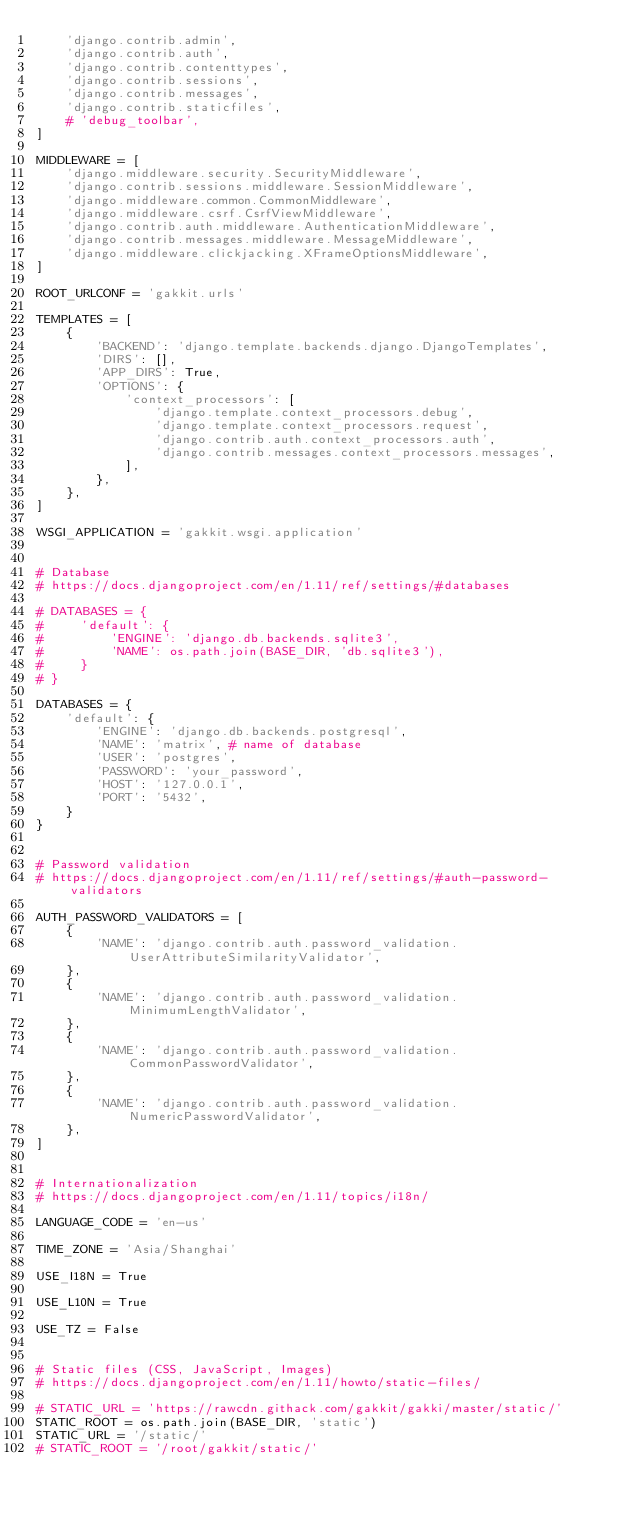<code> <loc_0><loc_0><loc_500><loc_500><_Python_>    'django.contrib.admin',
    'django.contrib.auth',
    'django.contrib.contenttypes',
    'django.contrib.sessions',
    'django.contrib.messages',
    'django.contrib.staticfiles',
    # 'debug_toolbar',
]

MIDDLEWARE = [
    'django.middleware.security.SecurityMiddleware',
    'django.contrib.sessions.middleware.SessionMiddleware',
    'django.middleware.common.CommonMiddleware',
    'django.middleware.csrf.CsrfViewMiddleware',
    'django.contrib.auth.middleware.AuthenticationMiddleware',
    'django.contrib.messages.middleware.MessageMiddleware',
    'django.middleware.clickjacking.XFrameOptionsMiddleware',
]

ROOT_URLCONF = 'gakkit.urls'

TEMPLATES = [
    {
        'BACKEND': 'django.template.backends.django.DjangoTemplates',
        'DIRS': [],
        'APP_DIRS': True,
        'OPTIONS': {
            'context_processors': [
                'django.template.context_processors.debug',
                'django.template.context_processors.request',
                'django.contrib.auth.context_processors.auth',
                'django.contrib.messages.context_processors.messages',
            ],
        },
    },
]

WSGI_APPLICATION = 'gakkit.wsgi.application'


# Database
# https://docs.djangoproject.com/en/1.11/ref/settings/#databases

# DATABASES = {
#     'default': {
#         'ENGINE': 'django.db.backends.sqlite3',
#         'NAME': os.path.join(BASE_DIR, 'db.sqlite3'),
#     }
# }

DATABASES = {
    'default': {
        'ENGINE': 'django.db.backends.postgresql',
        'NAME': 'matrix', # name of database
        'USER': 'postgres',
        'PASSWORD': 'your_password',
        'HOST': '127.0.0.1',
        'PORT': '5432',
    }
}


# Password validation
# https://docs.djangoproject.com/en/1.11/ref/settings/#auth-password-validators

AUTH_PASSWORD_VALIDATORS = [
    {
        'NAME': 'django.contrib.auth.password_validation.UserAttributeSimilarityValidator',
    },
    {
        'NAME': 'django.contrib.auth.password_validation.MinimumLengthValidator',
    },
    {
        'NAME': 'django.contrib.auth.password_validation.CommonPasswordValidator',
    },
    {
        'NAME': 'django.contrib.auth.password_validation.NumericPasswordValidator',
    },
]


# Internationalization
# https://docs.djangoproject.com/en/1.11/topics/i18n/

LANGUAGE_CODE = 'en-us'

TIME_ZONE = 'Asia/Shanghai'

USE_I18N = True

USE_L10N = True

USE_TZ = False


# Static files (CSS, JavaScript, Images)
# https://docs.djangoproject.com/en/1.11/howto/static-files/

# STATIC_URL = 'https://rawcdn.githack.com/gakkit/gakki/master/static/'
STATIC_ROOT = os.path.join(BASE_DIR, 'static')
STATIC_URL = '/static/'
# STATIC_ROOT = '/root/gakkit/static/'
</code> 